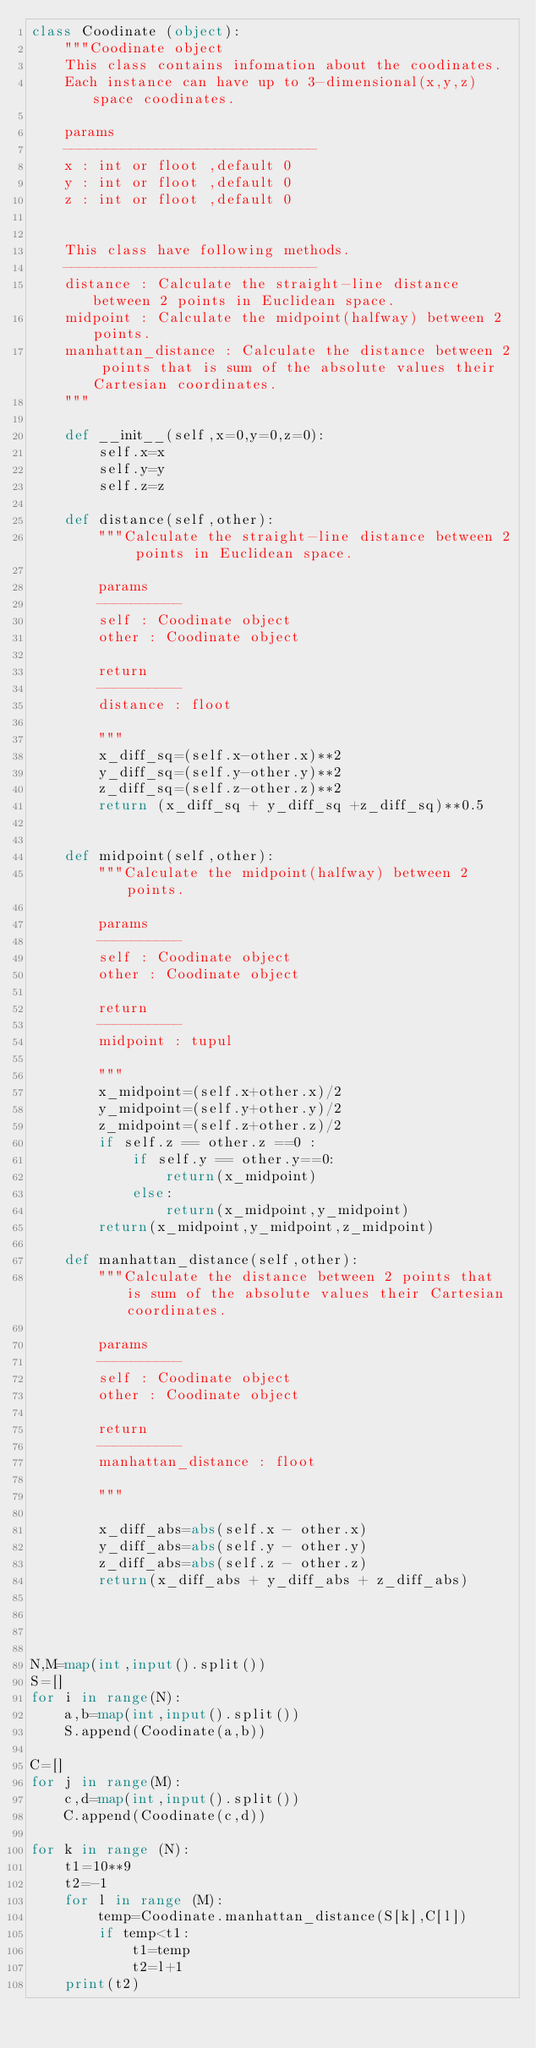Convert code to text. <code><loc_0><loc_0><loc_500><loc_500><_Python_>class Coodinate (object):
    """Coodinate object
    This class contains infomation about the coodinates.
    Each instance can have up to 3-dimensional(x,y,z) space coodinates.
    
    params
    ------------------------------
    x : int or floot ,default 0
    y : int or floot ,default 0
    z : int or floot ,default 0


    This class have following methods.
    ------------------------------
    distance : Calculate the straight-line distance between 2 points in Euclidean space.
    midpoint : Calculate the midpoint(halfway) between 2 points.
    manhattan_distance : Calculate the distance between 2 points that is sum of the absolute values their Cartesian coordinates.
    """

    def __init__(self,x=0,y=0,z=0):
        self.x=x
        self.y=y
        self.z=z
    
    def distance(self,other):
        """Calculate the straight-line distance between 2 points in Euclidean space.

        params
        ----------
        self : Coodinate object
        other : Coodinate object

        return
        ----------
        distance : floot

        """
        x_diff_sq=(self.x-other.x)**2
        y_diff_sq=(self.y-other.y)**2
        z_diff_sq=(self.z-other.z)**2
        return (x_diff_sq + y_diff_sq +z_diff_sq)**0.5
    

    def midpoint(self,other):
        """Calculate the midpoint(halfway) between 2 points.

        params
        ----------
        self : Coodinate object
        other : Coodinate object

        return
        ----------
        midpoint : tupul
        
        """
        x_midpoint=(self.x+other.x)/2
        y_midpoint=(self.y+other.y)/2
        z_midpoint=(self.z+other.z)/2
        if self.z == other.z ==0 :
            if self.y == other.y==0:
                return(x_midpoint)
            else:
                return(x_midpoint,y_midpoint) 
        return(x_midpoint,y_midpoint,z_midpoint)

    def manhattan_distance(self,other):
        """Calculate the distance between 2 points that is sum of the absolute values their Cartesian coordinates.

        params
        ----------
        self : Coodinate object
        other : Coodinate object

        return
        ----------
        manhattan_distance : floot

        """

        x_diff_abs=abs(self.x - other.x)
        y_diff_abs=abs(self.y - other.y)
        z_diff_abs=abs(self.z - other.z)
        return(x_diff_abs + y_diff_abs + z_diff_abs)




N,M=map(int,input().split())
S=[]
for i in range(N):
    a,b=map(int,input().split())
    S.append(Coodinate(a,b))

C=[]
for j in range(M):
    c,d=map(int,input().split())
    C.append(Coodinate(c,d))

for k in range (N):
    t1=10**9
    t2=-1
    for l in range (M):
        temp=Coodinate.manhattan_distance(S[k],C[l])
        if temp<t1:
            t1=temp
            t2=l+1
    print(t2)</code> 